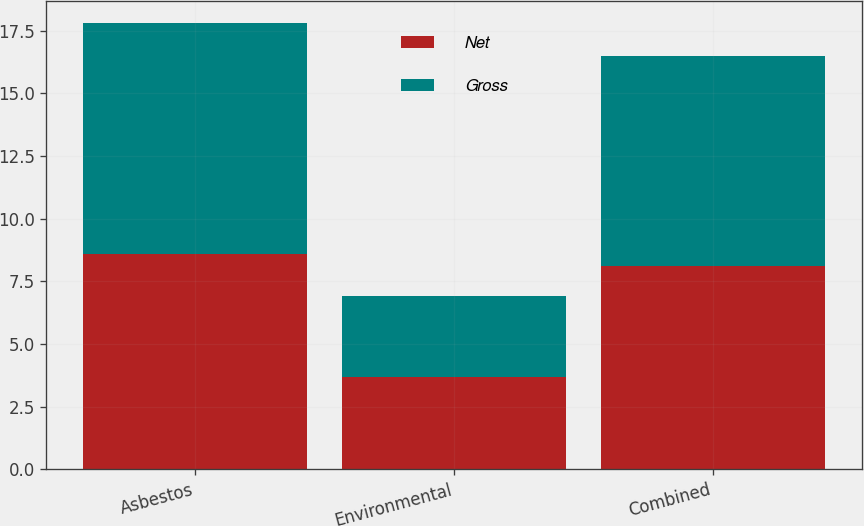Convert chart to OTSL. <chart><loc_0><loc_0><loc_500><loc_500><stacked_bar_chart><ecel><fcel>Asbestos<fcel>Environmental<fcel>Combined<nl><fcel>Net<fcel>8.6<fcel>3.7<fcel>8.1<nl><fcel>Gross<fcel>9.2<fcel>3.2<fcel>8.4<nl></chart> 